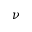Convert formula to latex. <formula><loc_0><loc_0><loc_500><loc_500>\nu</formula> 